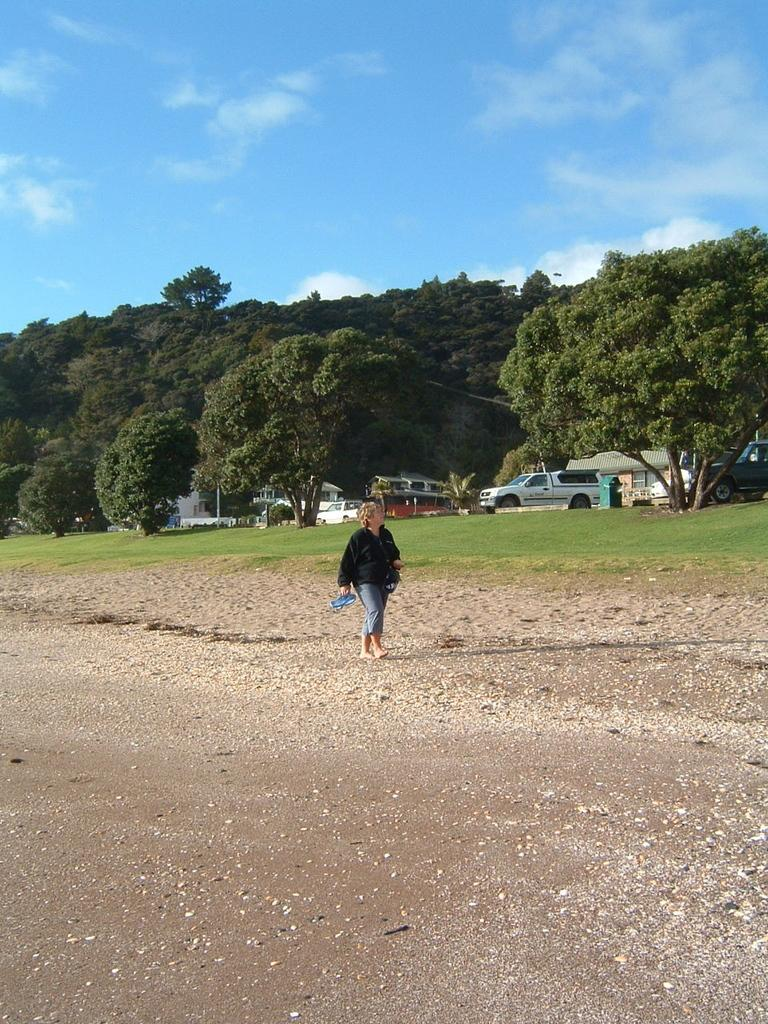Who is the main subject in the image? There is a lady in the center of the image. What is the lady doing in the image? The lady is walking on the ground. What can be seen in the background of the image? There are trees, cars, at least one building, and the sky visible in the background of the image. What is the condition of the sky in the image? The sky is visible in the background of the image, and there are clouds present. Can you hear the whistle of the bird in the image? There is no bird or whistle present in the image; it features a lady walking on the ground with a background of trees, cars, a building, and the sky. 